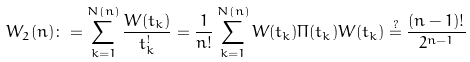<formula> <loc_0><loc_0><loc_500><loc_500>W _ { 2 } ( n ) \colon = \sum _ { k = 1 } ^ { N ( n ) } \frac { W ( t _ { k } ) } { t _ { k } ^ { ! } } = \frac { 1 } { n ! } \sum _ { k = 1 } ^ { N ( n ) } W ( t _ { k } ) \Pi ( t _ { k } ) W ( t _ { k } ) \stackrel { ? } { = } \frac { ( n - 1 ) ! } { 2 ^ { n - 1 } }</formula> 